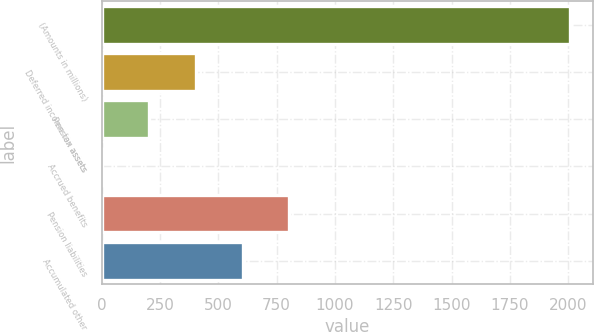<chart> <loc_0><loc_0><loc_500><loc_500><bar_chart><fcel>(Amounts in millions)<fcel>Deferred income tax assets<fcel>Pension assets<fcel>Accrued benefits<fcel>Pension liabilities<fcel>Accumulated other<nl><fcel>2006<fcel>404.08<fcel>203.84<fcel>3.6<fcel>804.56<fcel>604.32<nl></chart> 